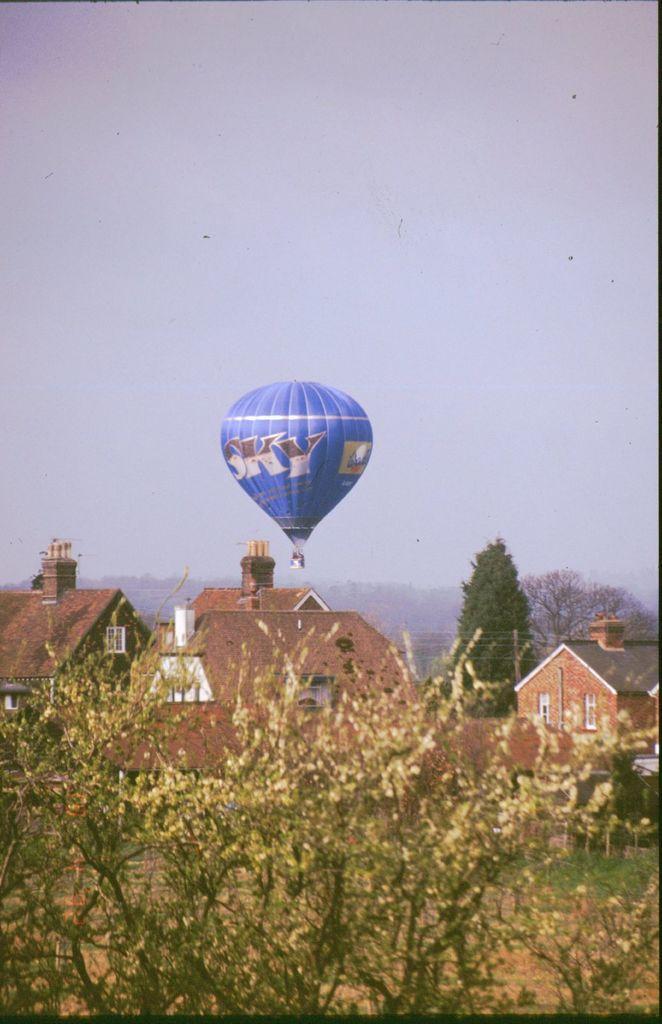In one or two sentences, can you explain what this image depicts? In this image, we can see a parachute is flying. At the bottom, we can see few houses, trees. Top of the image, there is a sky. 